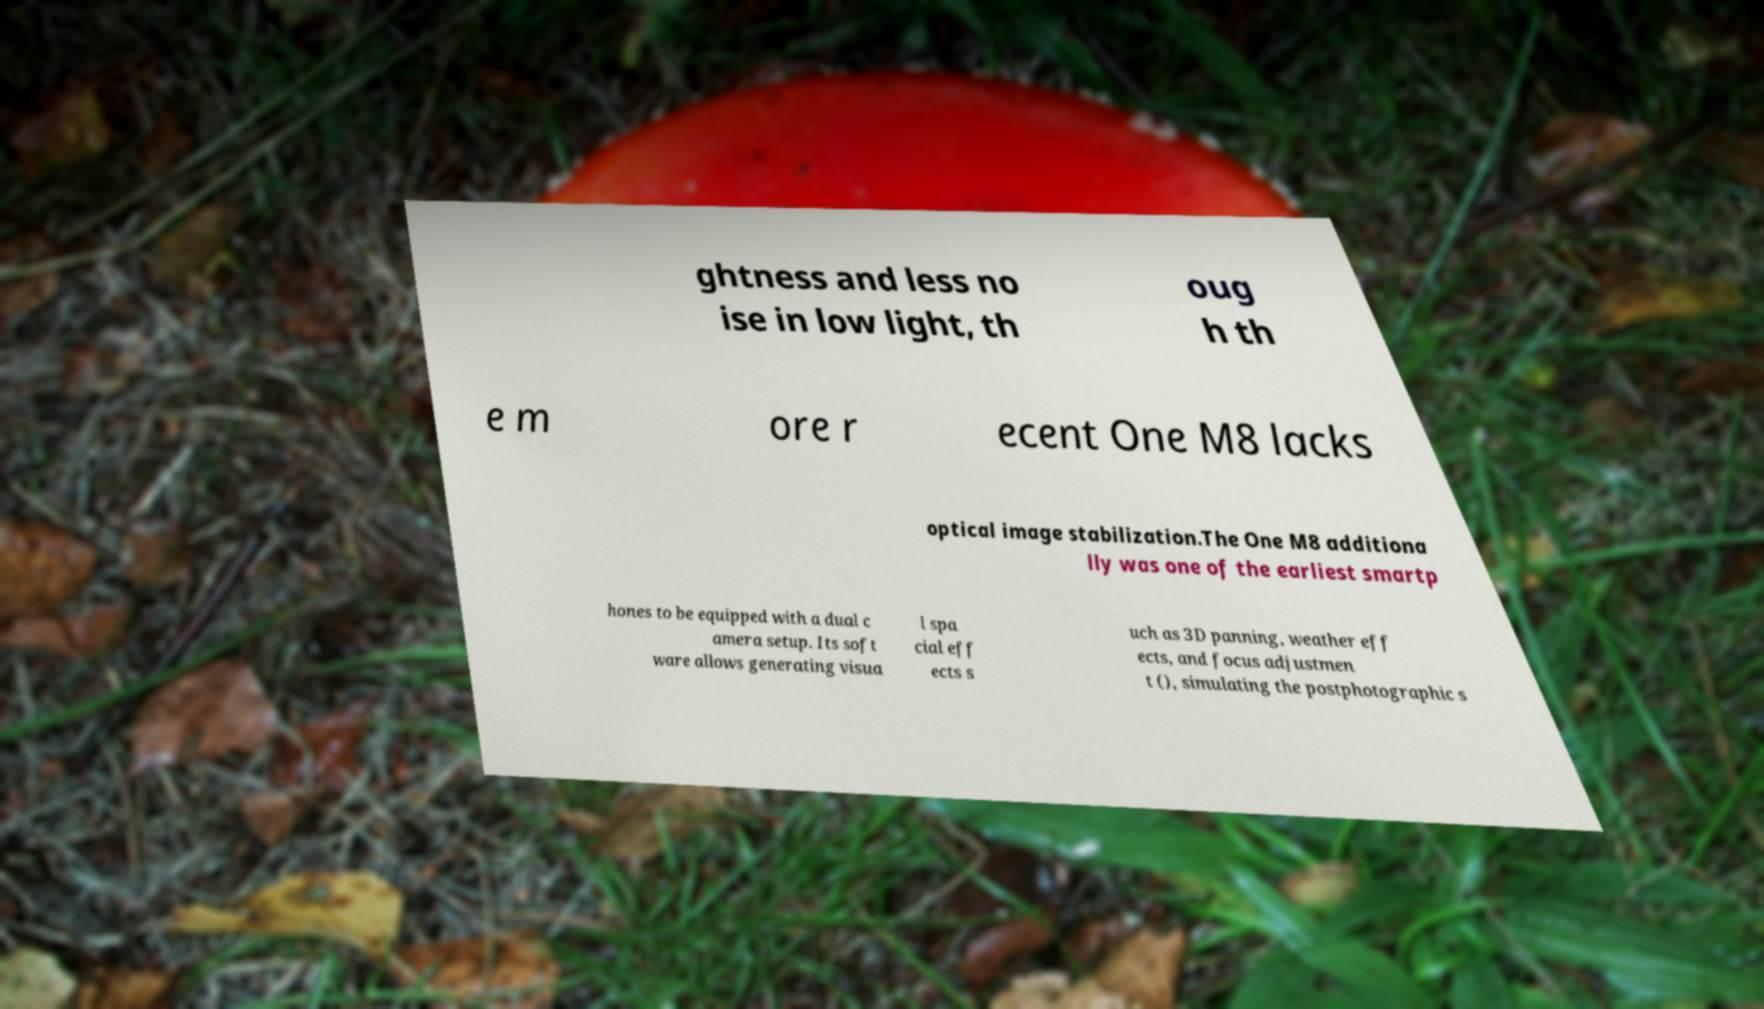Please read and relay the text visible in this image. What does it say? ghtness and less no ise in low light, th oug h th e m ore r ecent One M8 lacks optical image stabilization.The One M8 additiona lly was one of the earliest smartp hones to be equipped with a dual c amera setup. Its soft ware allows generating visua l spa cial eff ects s uch as 3D panning, weather eff ects, and focus adjustmen t (), simulating the postphotographic s 